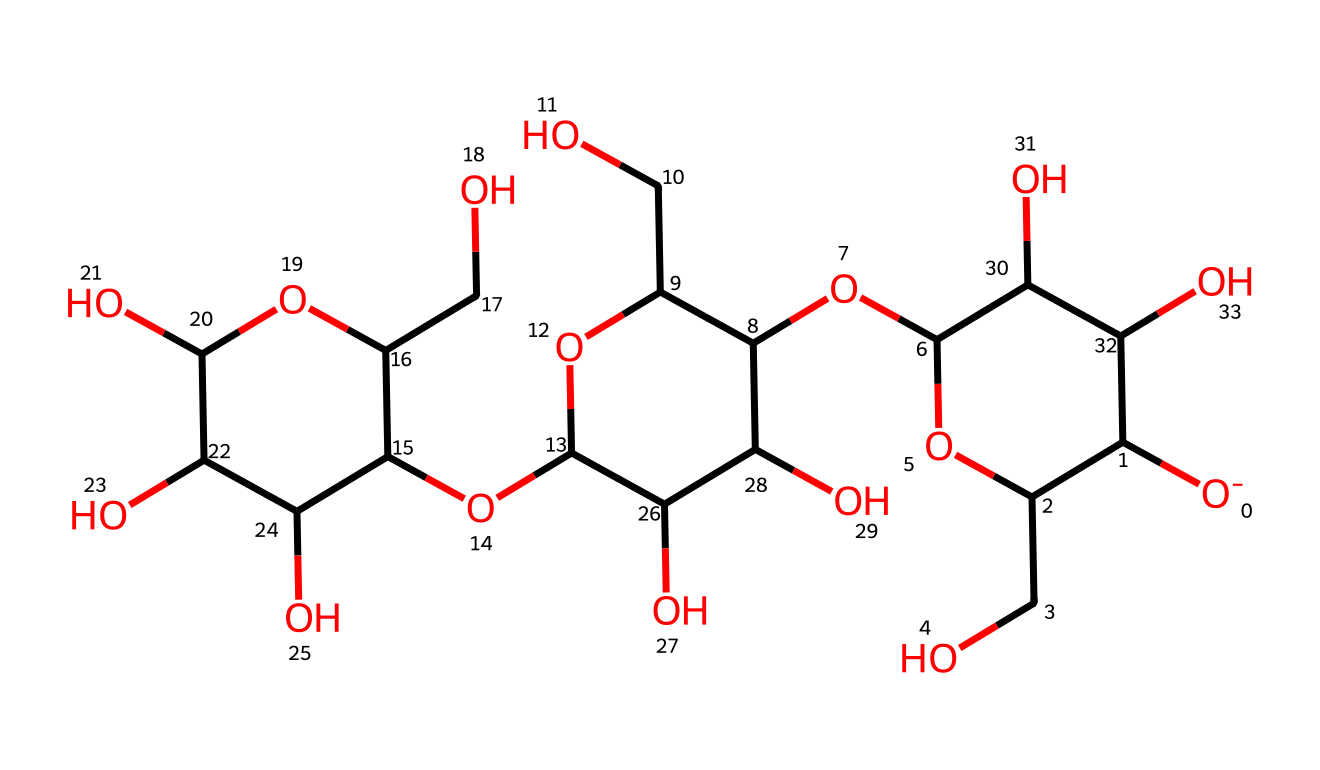What is the primary functional group present in this chemical? The structure contains multiple hydroxyl groups (-OH), which are characteristic of carbohydrates, specifically cellulose. Each of the carbon atoms in the cyclic structure is bonded to a hydroxyl group.
Answer: hydroxyl How many carbon atoms are present in this structure? By analyzing the SMILES representation, we can count the number of carbon atoms; there are 6 distinct carbon rings and additional carbon atoms connected to each ring. In total, there are 14 carbon atoms.
Answer: 14 What type of molecule is this, based on its properties? This structure is characteristically a non-electrolyte, as it does not dissociate into ions in solution. Non-electrolytes are typically organic compounds, and this chemical fits that category due to its covalent bonds and lack of ionic character.
Answer: non-electrolyte How many oxygen atoms are in this chemical? The counting of oxygen atoms indicates an extensive number of -OH groups; the structure shows a total of 8 oxygen atoms from the various parts of the cyclic structure and hydroxyl groups.
Answer: 8 Is this molecule hydrophilic or hydrophobic? This molecule is hydrophilic due to the presence of numerous polar hydroxyl groups that can form hydrogen bonds with water molecules, leading to good solubility in water and interaction with other hydrophilic substances.
Answer: hydrophilic What is the implication of multiple hydroxyl groups on the solubility of this chemical? Multiple hydroxyl groups increase the solubility of this compound in water due to their ability to form hydrogen bonds, allowing for greater interaction with water molecules. This characteristic is typical for cellulose and contributes to the hydrophilic nature of cotton fabrics.
Answer: increased solubility 